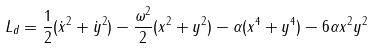<formula> <loc_0><loc_0><loc_500><loc_500>L _ { d } = \frac { 1 } { 2 } ( \dot { x } ^ { 2 } + \dot { y } ^ { 2 } ) - \frac { \omega ^ { 2 } } { 2 } ( x ^ { 2 } + y ^ { 2 } ) - \alpha ( x ^ { 4 } + y ^ { 4 } ) - 6 \alpha x ^ { 2 } y ^ { 2 }</formula> 